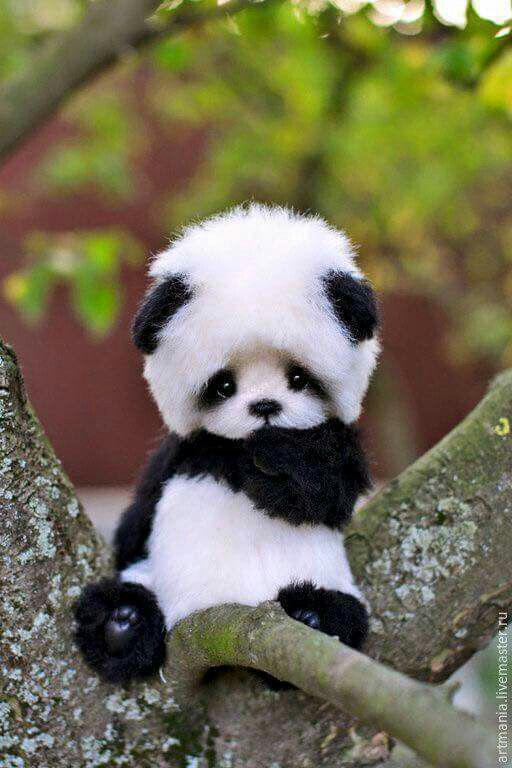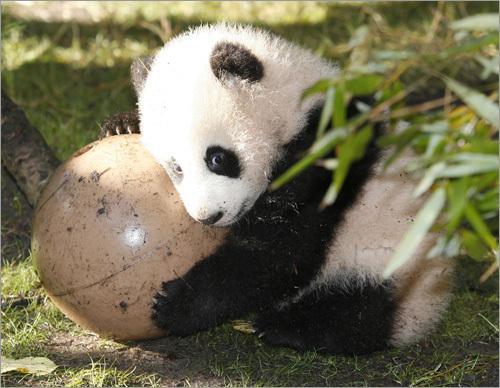The first image is the image on the left, the second image is the image on the right. Analyze the images presented: Is the assertion "One of the images show a single panda holding an object." valid? Answer yes or no. Yes. The first image is the image on the left, the second image is the image on the right. Examine the images to the left and right. Is the description "An image shows one panda playing with a toy, with its front paws grasping the object." accurate? Answer yes or no. Yes. 